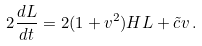<formula> <loc_0><loc_0><loc_500><loc_500>2 \frac { d L } { d t } = 2 ( 1 + v ^ { 2 } ) H L + { \tilde { c } } v \, .</formula> 